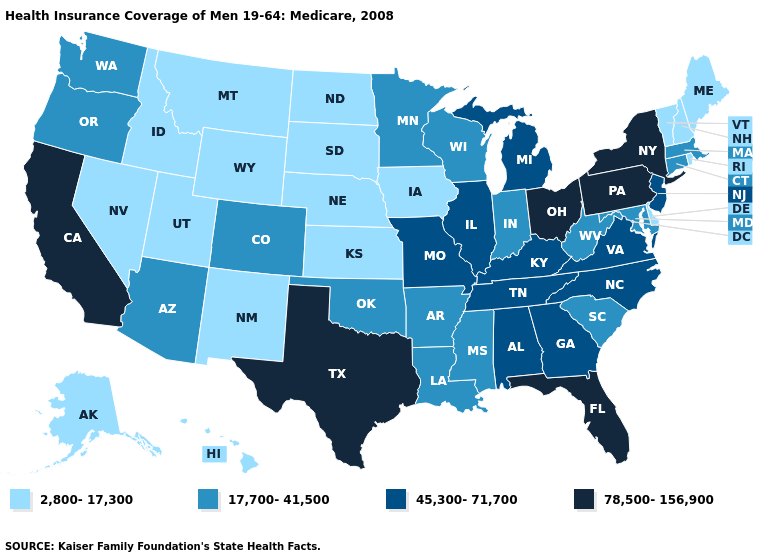Among the states that border Colorado , which have the lowest value?
Write a very short answer. Kansas, Nebraska, New Mexico, Utah, Wyoming. What is the value of Idaho?
Write a very short answer. 2,800-17,300. What is the value of Vermont?
Quick response, please. 2,800-17,300. Among the states that border New York , does Connecticut have the lowest value?
Keep it brief. No. What is the value of Oregon?
Give a very brief answer. 17,700-41,500. What is the value of Illinois?
Short answer required. 45,300-71,700. What is the highest value in the USA?
Be succinct. 78,500-156,900. Does Louisiana have the same value as Nevada?
Write a very short answer. No. What is the value of Georgia?
Keep it brief. 45,300-71,700. How many symbols are there in the legend?
Answer briefly. 4. Does the map have missing data?
Answer briefly. No. Does Oklahoma have a higher value than Hawaii?
Keep it brief. Yes. Name the states that have a value in the range 78,500-156,900?
Be succinct. California, Florida, New York, Ohio, Pennsylvania, Texas. What is the highest value in states that border Minnesota?
Give a very brief answer. 17,700-41,500. Name the states that have a value in the range 45,300-71,700?
Answer briefly. Alabama, Georgia, Illinois, Kentucky, Michigan, Missouri, New Jersey, North Carolina, Tennessee, Virginia. 